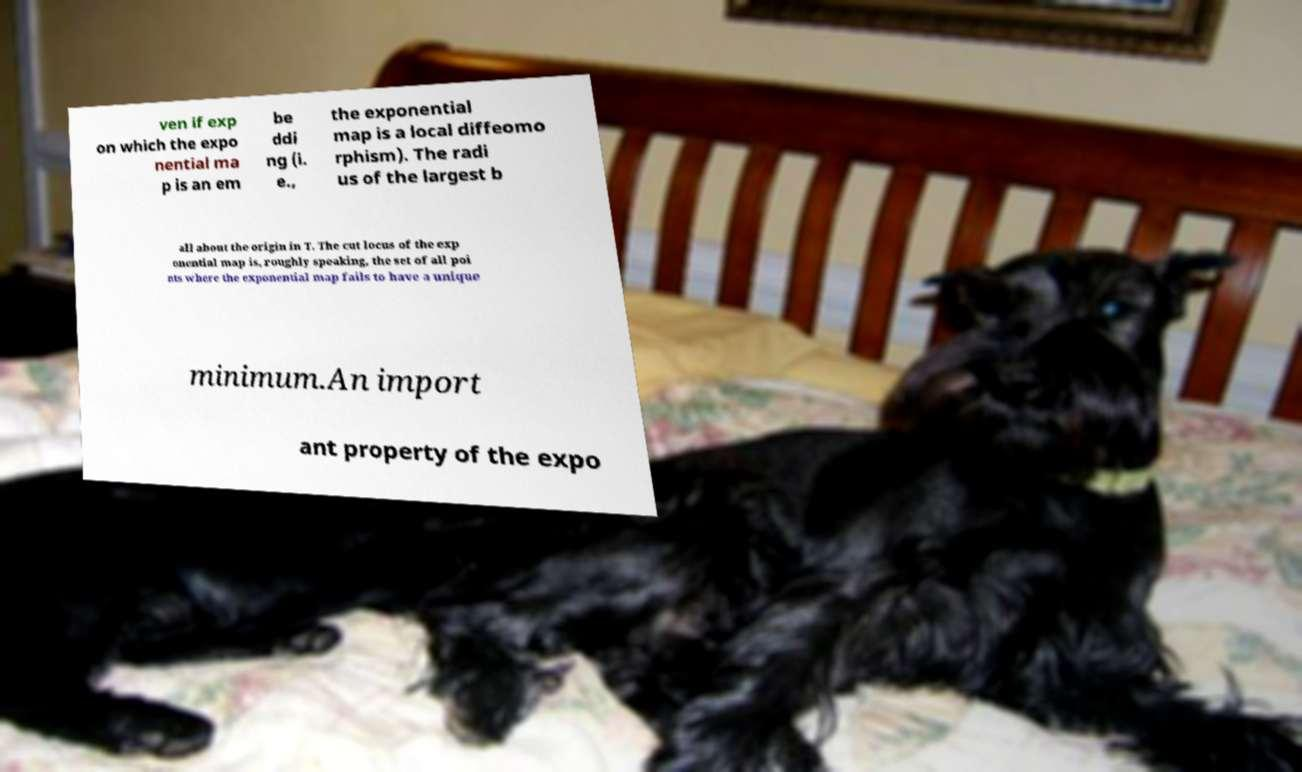There's text embedded in this image that I need extracted. Can you transcribe it verbatim? ven if exp on which the expo nential ma p is an em be ddi ng (i. e., the exponential map is a local diffeomo rphism). The radi us of the largest b all about the origin in T. The cut locus of the exp onential map is, roughly speaking, the set of all poi nts where the exponential map fails to have a unique minimum.An import ant property of the expo 